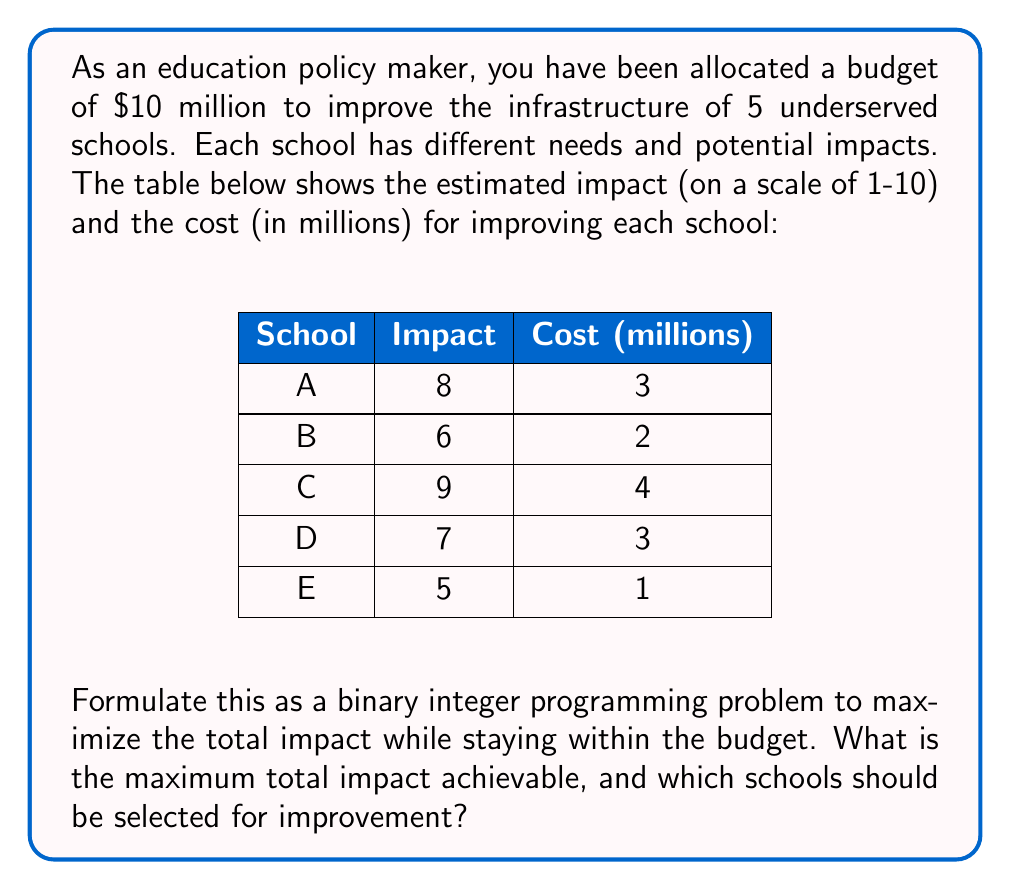Give your solution to this math problem. To solve this problem, we'll use binary integer programming. Let's follow these steps:

1) Define decision variables:
   Let $x_i$ be a binary variable for each school $i$ (A, B, C, D, E)
   $x_i = 1$ if school $i$ is selected for improvement, 0 otherwise

2) Formulate the objective function:
   Maximize $Z = 8x_A + 6x_B + 9x_C + 7x_D + 5x_E$

3) Formulate the constraints:
   Budget constraint: $3x_A + 2x_B + 4x_C + 3x_D + x_E \leq 10$
   Binary constraints: $x_i \in \{0,1\}$ for all $i$

4) Solve the problem:
   We can solve this using branch and bound method or using solver software. 
   The optimal solution is:
   $x_A = 1, x_B = 1, x_C = 1, x_D = 0, x_E = 1$

5) Interpret the results:
   Select schools A, B, C, and E for improvement.
   Total cost: $3 + 2 + 4 + 1 = 10$ million (exactly meeting the budget)
   Total impact: $8 + 6 + 9 + 5 = 28$

Therefore, the maximum total impact achievable is 28, by selecting schools A, B, C, and E for improvement.
Answer: Maximum total impact: 28
Schools to be selected: A, B, C, and E 